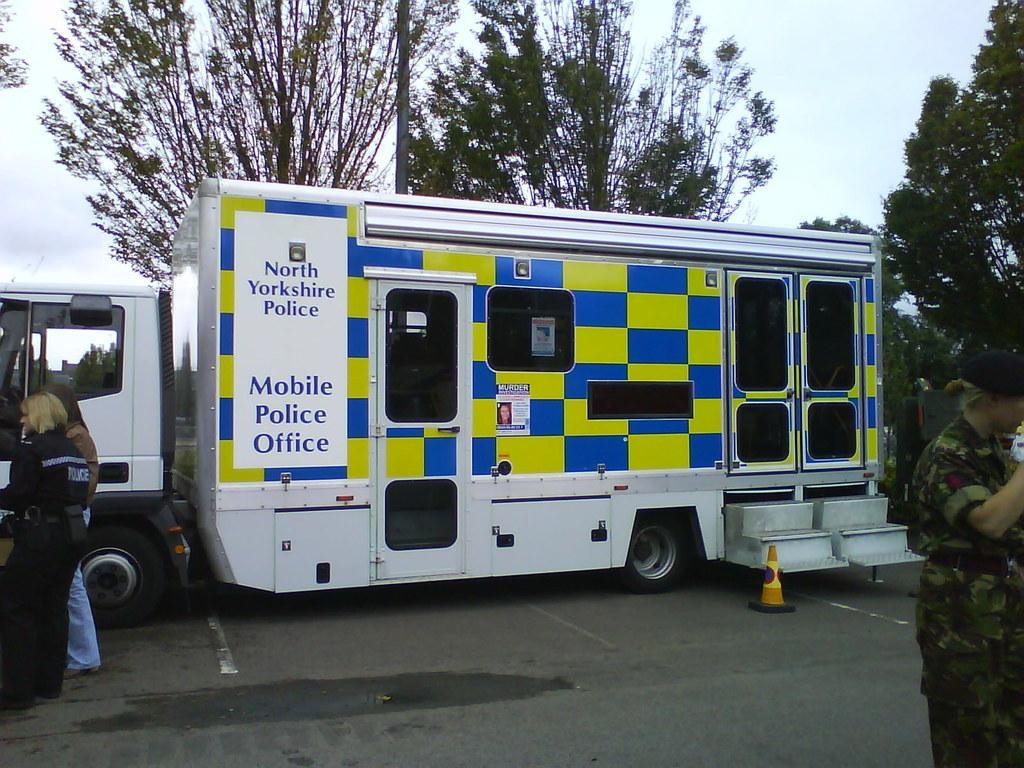Describe this image in one or two sentences. This picture is clicked outside. In the center we can see a white color vehicle seems to be parked on the road and we can see a safety cone placed on the ground. On the left corner we can see the two persons and we can see the text on the vehicle. On the right corner we can see a person wearing uniform and standing and we can see the stairs. In the background we can see the sky, trees and some other objects. 